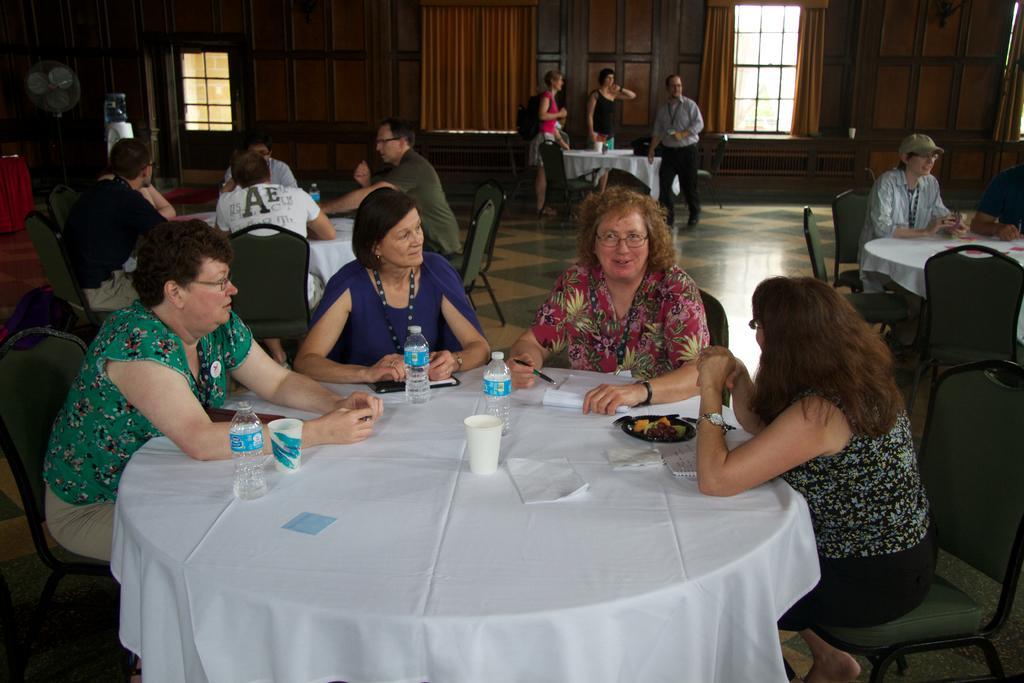How would you summarize this image in a sentence or two? There are group of people sitting on the chairs. This is a table covered with white cloth. This is a paper glass,water bottles,paper,plate of food,book and some object placed on the table. At background I can see windows with curtains hanging. This looks like a door and here I can see an fan. 